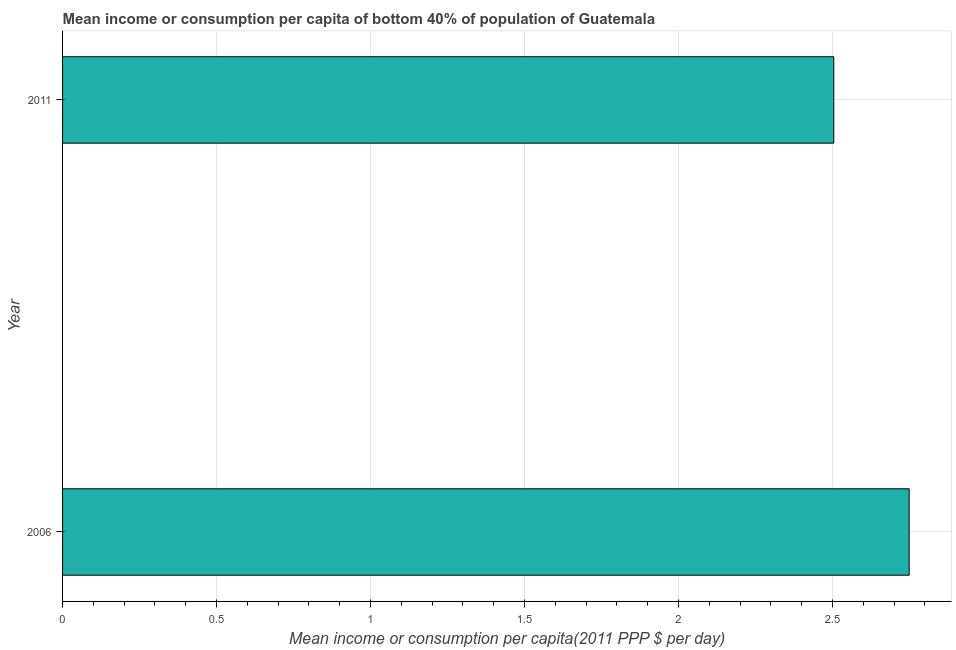Does the graph contain any zero values?
Keep it short and to the point. No. What is the title of the graph?
Your answer should be compact. Mean income or consumption per capita of bottom 40% of population of Guatemala. What is the label or title of the X-axis?
Provide a short and direct response. Mean income or consumption per capita(2011 PPP $ per day). What is the mean income or consumption in 2006?
Offer a very short reply. 2.75. Across all years, what is the maximum mean income or consumption?
Provide a succinct answer. 2.75. Across all years, what is the minimum mean income or consumption?
Provide a short and direct response. 2.5. In which year was the mean income or consumption maximum?
Keep it short and to the point. 2006. What is the sum of the mean income or consumption?
Ensure brevity in your answer.  5.25. What is the difference between the mean income or consumption in 2006 and 2011?
Provide a short and direct response. 0.24. What is the average mean income or consumption per year?
Ensure brevity in your answer.  2.63. What is the median mean income or consumption?
Offer a very short reply. 2.63. Do a majority of the years between 2006 and 2011 (inclusive) have mean income or consumption greater than 0.3 $?
Keep it short and to the point. Yes. What is the ratio of the mean income or consumption in 2006 to that in 2011?
Your answer should be compact. 1.1. How many years are there in the graph?
Keep it short and to the point. 2. What is the difference between two consecutive major ticks on the X-axis?
Offer a terse response. 0.5. Are the values on the major ticks of X-axis written in scientific E-notation?
Your response must be concise. No. What is the Mean income or consumption per capita(2011 PPP $ per day) of 2006?
Provide a succinct answer. 2.75. What is the Mean income or consumption per capita(2011 PPP $ per day) in 2011?
Offer a terse response. 2.5. What is the difference between the Mean income or consumption per capita(2011 PPP $ per day) in 2006 and 2011?
Offer a terse response. 0.24. What is the ratio of the Mean income or consumption per capita(2011 PPP $ per day) in 2006 to that in 2011?
Your response must be concise. 1.1. 